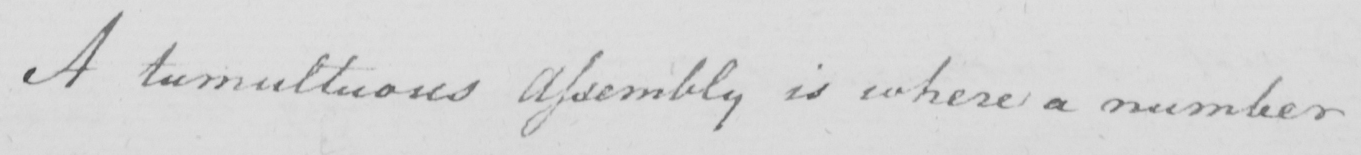What text is written in this handwritten line? A tumultuous Assembly is where a number 